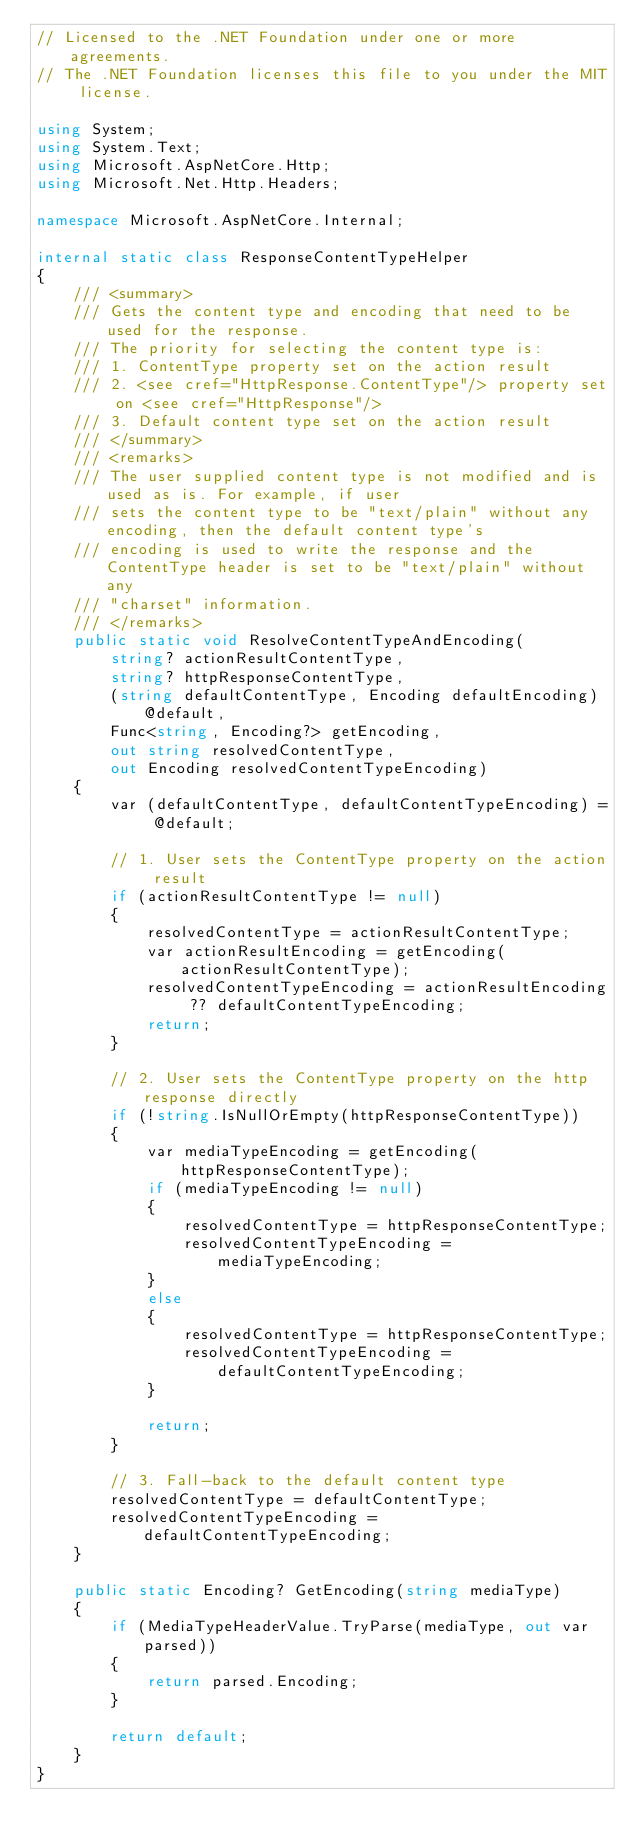Convert code to text. <code><loc_0><loc_0><loc_500><loc_500><_C#_>// Licensed to the .NET Foundation under one or more agreements.
// The .NET Foundation licenses this file to you under the MIT license.

using System;
using System.Text;
using Microsoft.AspNetCore.Http;
using Microsoft.Net.Http.Headers;

namespace Microsoft.AspNetCore.Internal;

internal static class ResponseContentTypeHelper
{
    /// <summary>
    /// Gets the content type and encoding that need to be used for the response.
    /// The priority for selecting the content type is:
    /// 1. ContentType property set on the action result
    /// 2. <see cref="HttpResponse.ContentType"/> property set on <see cref="HttpResponse"/>
    /// 3. Default content type set on the action result
    /// </summary>
    /// <remarks>
    /// The user supplied content type is not modified and is used as is. For example, if user
    /// sets the content type to be "text/plain" without any encoding, then the default content type's
    /// encoding is used to write the response and the ContentType header is set to be "text/plain" without any
    /// "charset" information.
    /// </remarks>
    public static void ResolveContentTypeAndEncoding(
        string? actionResultContentType,
        string? httpResponseContentType,
        (string defaultContentType, Encoding defaultEncoding) @default,
        Func<string, Encoding?> getEncoding,
        out string resolvedContentType,
        out Encoding resolvedContentTypeEncoding)
    {
        var (defaultContentType, defaultContentTypeEncoding) = @default;

        // 1. User sets the ContentType property on the action result
        if (actionResultContentType != null)
        {
            resolvedContentType = actionResultContentType;
            var actionResultEncoding = getEncoding(actionResultContentType);
            resolvedContentTypeEncoding = actionResultEncoding ?? defaultContentTypeEncoding;
            return;
        }

        // 2. User sets the ContentType property on the http response directly
        if (!string.IsNullOrEmpty(httpResponseContentType))
        {
            var mediaTypeEncoding = getEncoding(httpResponseContentType);
            if (mediaTypeEncoding != null)
            {
                resolvedContentType = httpResponseContentType;
                resolvedContentTypeEncoding = mediaTypeEncoding;
            }
            else
            {
                resolvedContentType = httpResponseContentType;
                resolvedContentTypeEncoding = defaultContentTypeEncoding;
            }

            return;
        }

        // 3. Fall-back to the default content type
        resolvedContentType = defaultContentType;
        resolvedContentTypeEncoding = defaultContentTypeEncoding;
    }

    public static Encoding? GetEncoding(string mediaType)
    {
        if (MediaTypeHeaderValue.TryParse(mediaType, out var parsed))
        {
            return parsed.Encoding;
        }

        return default;
    }
}
</code> 